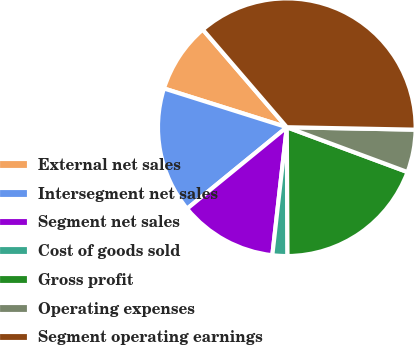Convert chart to OTSL. <chart><loc_0><loc_0><loc_500><loc_500><pie_chart><fcel>External net sales<fcel>Intersegment net sales<fcel>Segment net sales<fcel>Cost of goods sold<fcel>Gross profit<fcel>Operating expenses<fcel>Segment operating earnings<nl><fcel>8.83%<fcel>15.77%<fcel>12.3%<fcel>1.88%<fcel>19.25%<fcel>5.36%<fcel>36.61%<nl></chart> 